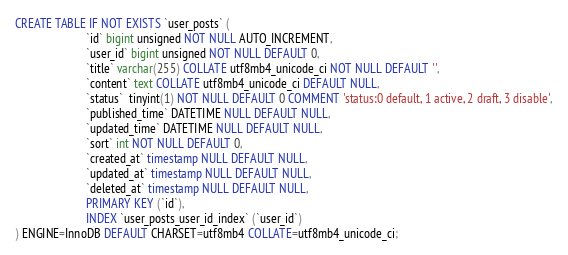Convert code to text. <code><loc_0><loc_0><loc_500><loc_500><_SQL_>CREATE TABLE IF NOT EXISTS `user_posts` (
                        `id` bigint unsigned NOT NULL AUTO_INCREMENT,
                        `user_id` bigint unsigned NOT NULL DEFAULT 0,
                        `title` varchar(255) COLLATE utf8mb4_unicode_ci NOT NULL DEFAULT '',
                        `content` text COLLATE utf8mb4_unicode_ci DEFAULT NULL,
                        `status`  tinyint(1) NOT NULL DEFAULT 0 COMMENT 'status:0 default, 1 active, 2 draft, 3 disable',
                        `published_time` DATETIME NULL DEFAULT NULL,
                        `updated_time` DATETIME NULL DEFAULT NULL,
                        `sort` int NOT NULL DEFAULT 0,
                        `created_at` timestamp NULL DEFAULT NULL,
                        `updated_at` timestamp NULL DEFAULT NULL,
                        `deleted_at` timestamp NULL DEFAULT NULL,
                        PRIMARY KEY (`id`),
                        INDEX `user_posts_user_id_index` (`user_id`)
) ENGINE=InnoDB DEFAULT CHARSET=utf8mb4 COLLATE=utf8mb4_unicode_ci;</code> 